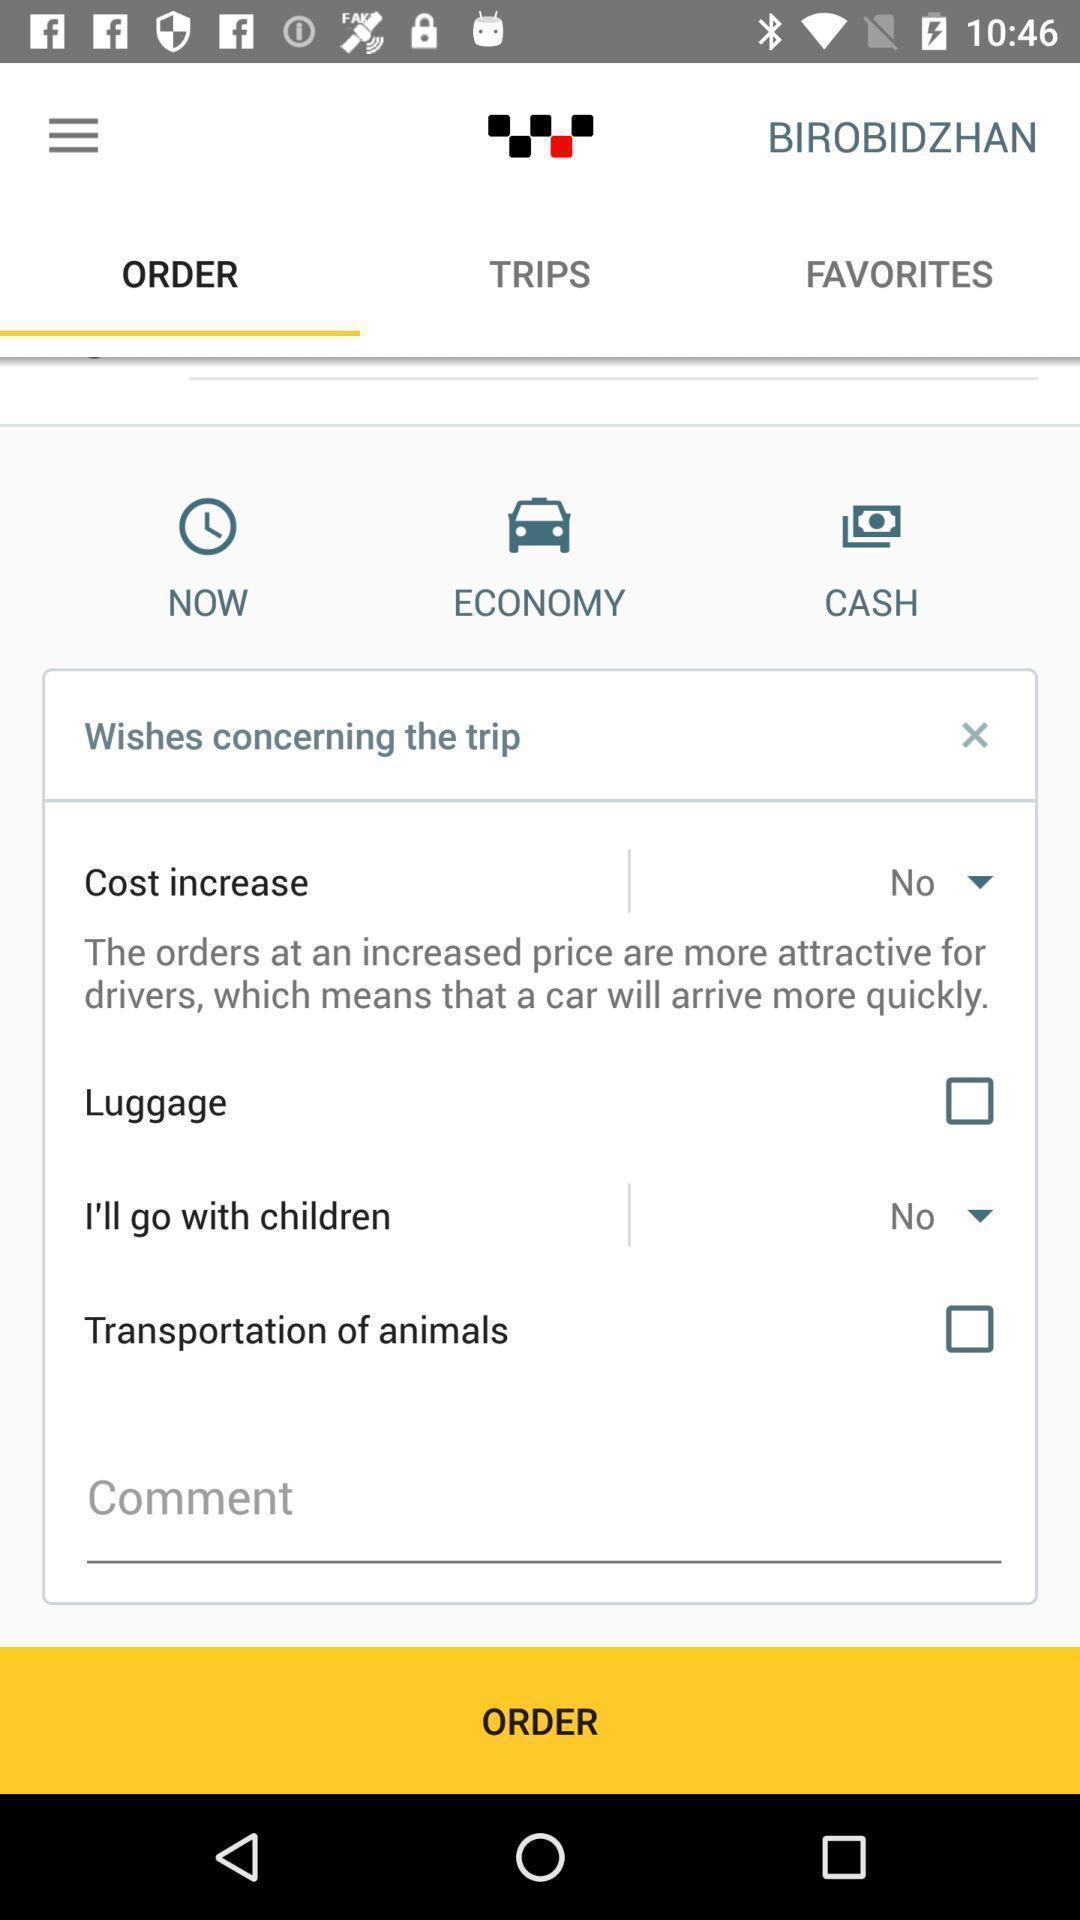Please provide a description for this image. Screen shows an order of a taxi. 